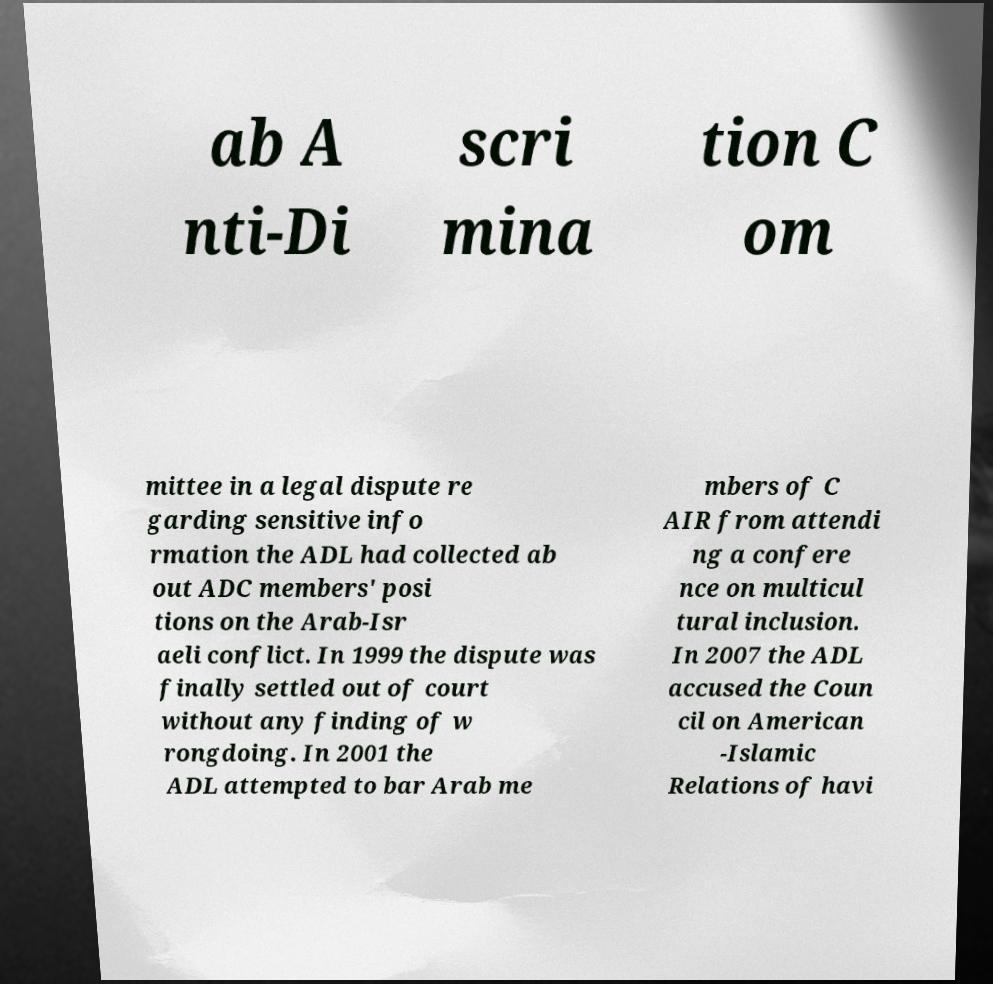Can you read and provide the text displayed in the image?This photo seems to have some interesting text. Can you extract and type it out for me? ab A nti-Di scri mina tion C om mittee in a legal dispute re garding sensitive info rmation the ADL had collected ab out ADC members' posi tions on the Arab-Isr aeli conflict. In 1999 the dispute was finally settled out of court without any finding of w rongdoing. In 2001 the ADL attempted to bar Arab me mbers of C AIR from attendi ng a confere nce on multicul tural inclusion. In 2007 the ADL accused the Coun cil on American -Islamic Relations of havi 